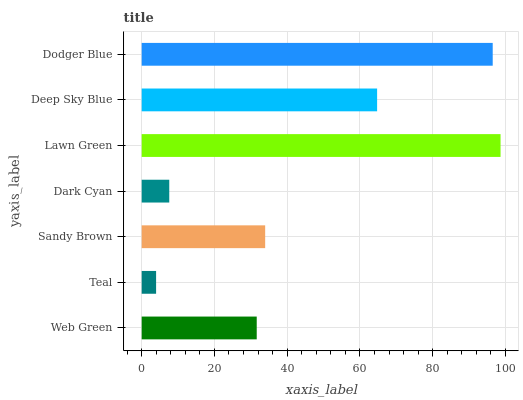Is Teal the minimum?
Answer yes or no. Yes. Is Lawn Green the maximum?
Answer yes or no. Yes. Is Sandy Brown the minimum?
Answer yes or no. No. Is Sandy Brown the maximum?
Answer yes or no. No. Is Sandy Brown greater than Teal?
Answer yes or no. Yes. Is Teal less than Sandy Brown?
Answer yes or no. Yes. Is Teal greater than Sandy Brown?
Answer yes or no. No. Is Sandy Brown less than Teal?
Answer yes or no. No. Is Sandy Brown the high median?
Answer yes or no. Yes. Is Sandy Brown the low median?
Answer yes or no. Yes. Is Deep Sky Blue the high median?
Answer yes or no. No. Is Dark Cyan the low median?
Answer yes or no. No. 